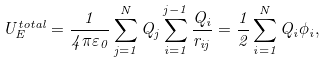Convert formula to latex. <formula><loc_0><loc_0><loc_500><loc_500>U _ { E } ^ { t o t a l } = { \frac { 1 } { 4 \pi \varepsilon _ { 0 } } } \sum _ { j = 1 } ^ { N } Q _ { j } \sum _ { i = 1 } ^ { j - 1 } { \frac { Q _ { i } } { r _ { i j } } } = { \frac { 1 } { 2 } } \sum _ { i = 1 } ^ { N } Q _ { i } \phi _ { i } ,</formula> 